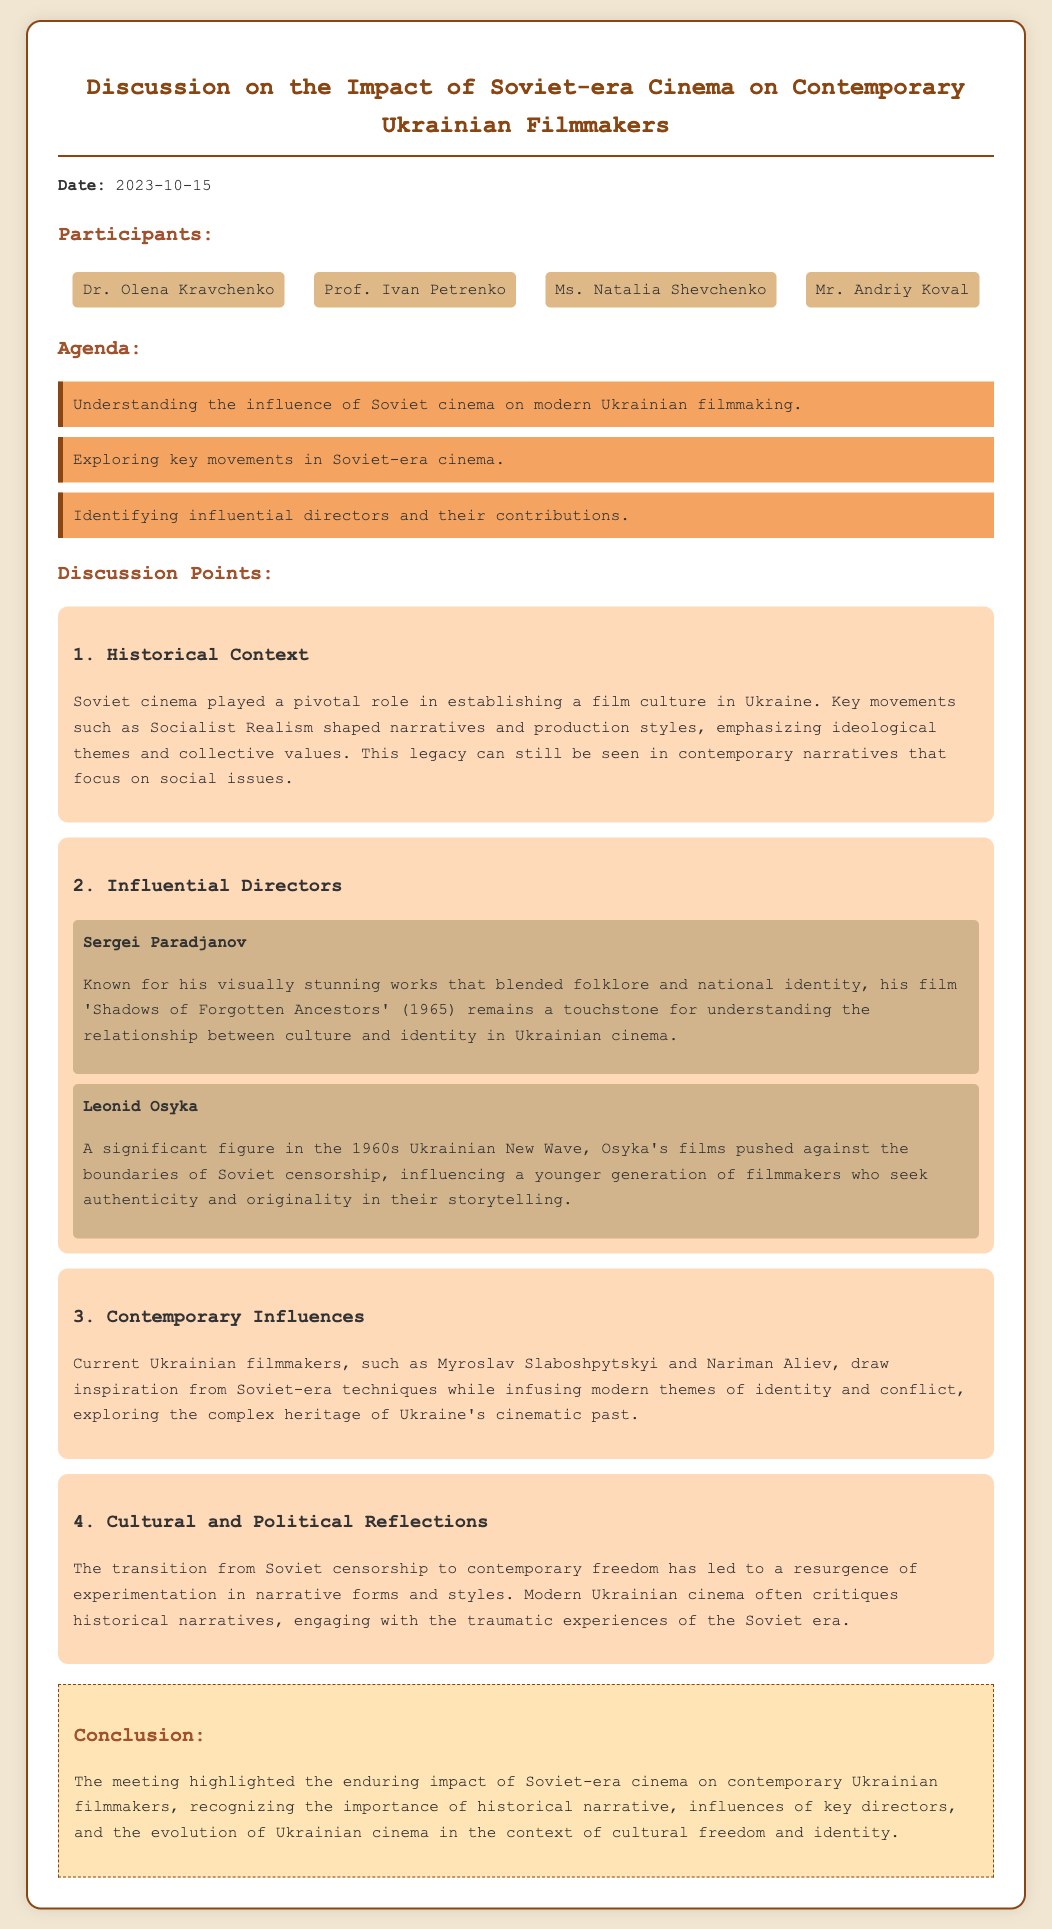What is the date of the meeting? The date of the meeting is explicitly mentioned at the beginning of the document.
Answer: 2023-10-15 Who is known for the film 'Shadows of Forgotten Ancestors'? The document states that Sergei Paradjanov is known for this film, making it a specific information retrieval question.
Answer: Sergei Paradjanov Which key movement in Soviet-era cinema influenced contemporary Ukrainian narratives? The discussion points indicate that Socialist Realism shaped narratives and production styles, which is relevant information.
Answer: Socialist Realism How many influential directors are discussed in the document? The document lists two influential directors in the discussion points, focusing on their significant contributions.
Answer: Two What is emphasized in the cultural and political reflections of contemporary Ukrainian cinema? The document points out that modern Ukrainian cinema critiques historical narratives, making it an essential understanding of the context.
Answer: Critiques historical narratives Who are two contemporary Ukrainian filmmakers mentioned in the document? The document discusses Myroslav Slaboshpytskyi and Nariman Aliev, providing specific names related to the contemporary influences.
Answer: Myroslav Slaboshpytskyi and Nariman Aliev What role did Soviet cinema play in establishing film culture in Ukraine? The document asserts that Soviet cinema played a pivotal role, which is a direct reference to its significant impact.
Answer: Pivotal role What essential theme is addressed in the first discussion point? The first discussion point discusses understanding the influence of Soviet cinema on modern Ukrainian filmmaking as the main theme.
Answer: Influence of Soviet cinema 